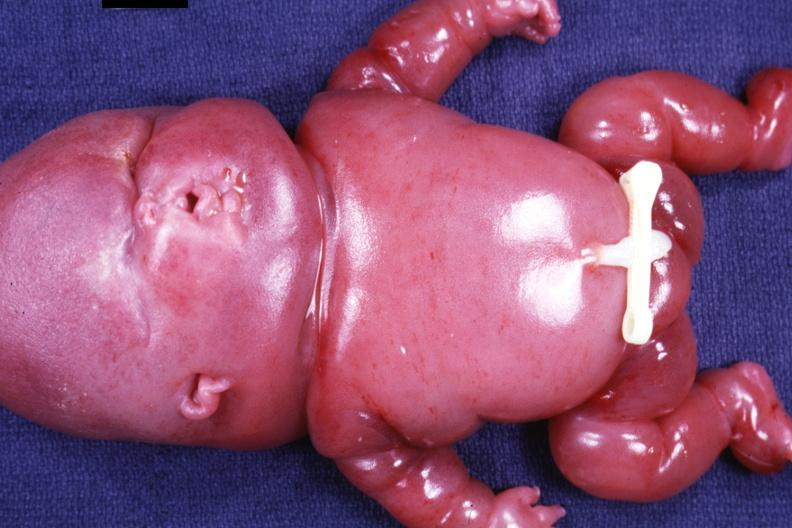s metastatic carcinoma prostate present?
Answer the question using a single word or phrase. No 